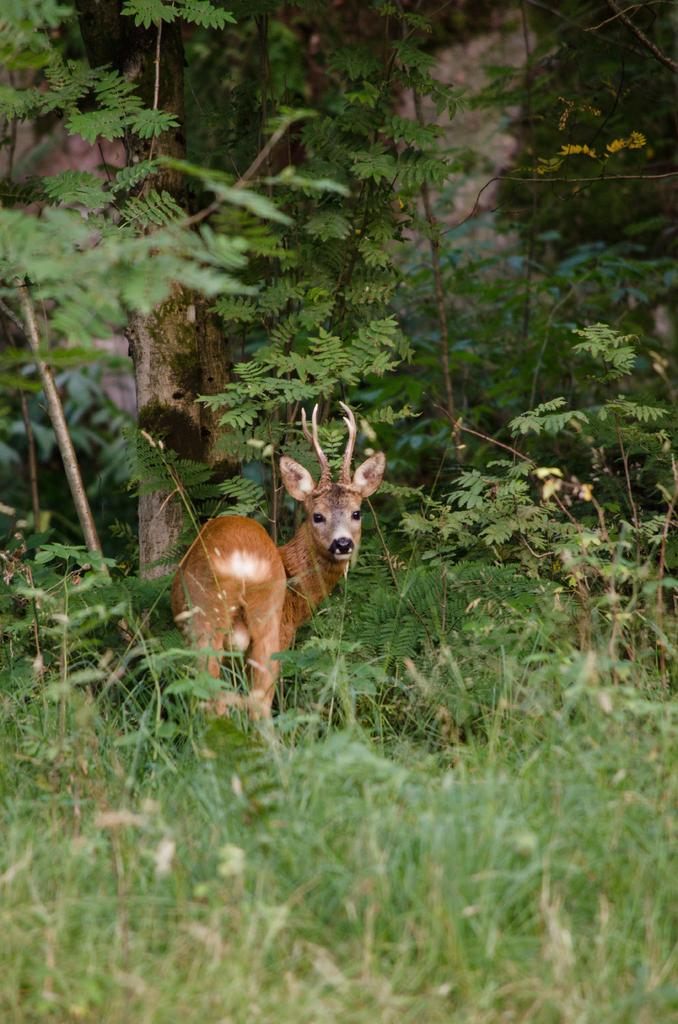What animal is present in the image? There is a deer in the image. What is the deer standing on? The deer is standing on the grass. What can be seen in the background of the image? There are trees and plants in the background of the image. What type of dress is the deer wearing in the image? Deer do not wear dresses, as they are animals and not human beings. 